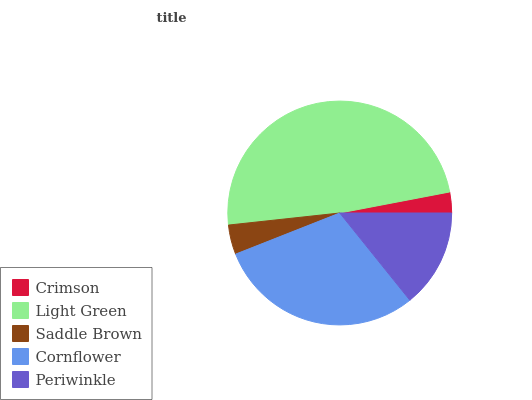Is Crimson the minimum?
Answer yes or no. Yes. Is Light Green the maximum?
Answer yes or no. Yes. Is Saddle Brown the minimum?
Answer yes or no. No. Is Saddle Brown the maximum?
Answer yes or no. No. Is Light Green greater than Saddle Brown?
Answer yes or no. Yes. Is Saddle Brown less than Light Green?
Answer yes or no. Yes. Is Saddle Brown greater than Light Green?
Answer yes or no. No. Is Light Green less than Saddle Brown?
Answer yes or no. No. Is Periwinkle the high median?
Answer yes or no. Yes. Is Periwinkle the low median?
Answer yes or no. Yes. Is Light Green the high median?
Answer yes or no. No. Is Saddle Brown the low median?
Answer yes or no. No. 